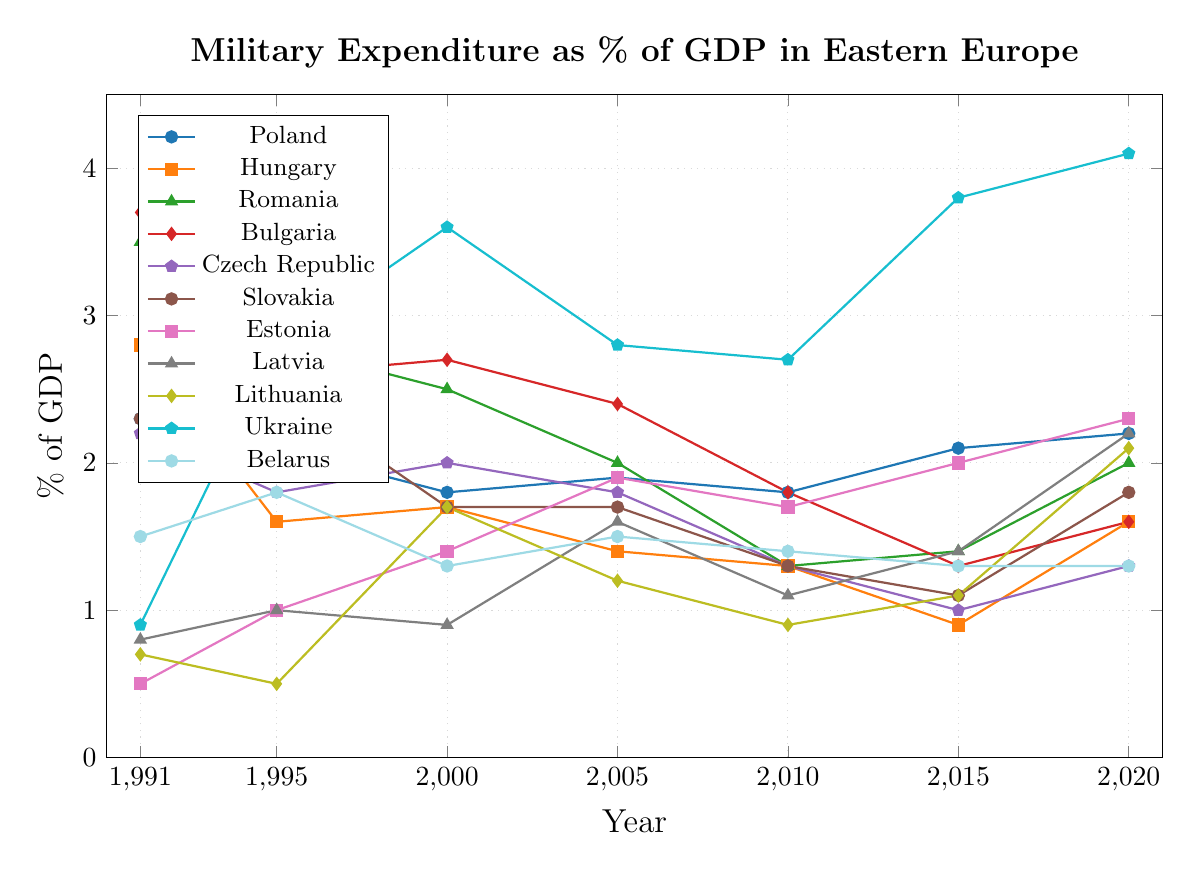What is the trend of military expenditure as a percentage of GDP for Estonia from 1991 to 2020? The figure shows a steady increase in military expenditure for Estonia, starting at 0.5% in 1991 and rising to 2.3% by 2020. The values are 0.5% (1991), 1.0% (1995), 1.4% (2000), 1.9% (2005), 1.7% (2010), 2.0% (2015), and 2.3% (2020).
Answer: Increasing Which country had the highest military expenditure as a percentage of GDP in 1991 and what was it? In 1991, Bulgaria had the highest military expenditure as a percentage of GDP at 3.7%. This can be determined by comparing the 1991 values for all countries.
Answer: Bulgaria, 3.7% Which country had the most significant decline in military expenditure as a percentage of GDP between 1991 and 2015? To determine this, calculate the difference between 1991 and 2015 for each country and identify the largest decline. Hungary's expenditure dropped from 2.8% in 1991 to 0.9% in 2015, a decrease of 1.9 percentage points.
Answer: Hungary Compare the military expenditures as a percentage of GDP in 2010 and 2020 for Ukraine and determine the difference. For Ukraine, the expenditure was 2.7% in 2010 and 4.1% in 2020. The difference is 4.1% - 2.7% = 1.4%.
Answer: 1.4% What is the average military expenditure as a percentage of GDP for Poland across all given years? Add the values for Poland (2.3 + 2.1 + 1.8 + 1.9 + 1.8 + 2.1 + 2.2) and divide by the number of years: (2.3 + 2.1 + 1.8 + 1.9 + 1.8 + 2.1 + 2.2) / 7 = 2.03.
Answer: 2.03% Which country had the highest military expenditure as a percentage of GDP in 2020, and what was the value? In 2020, Ukraine had the highest expenditure at 4.1%. By examining each country's value for 2020, Ukraine's 4.1% is the highest.
Answer: Ukraine, 4.1% By how much did Latvia's military expenditure as a percentage of GDP change from 2015 to 2020? In 2015, Latvia's expenditure was 1.4%, and in 2020 it was 2.2%. The change is 2.2% - 1.4% = 0.8%.
Answer: 0.8% What is the overall trend of military expenditure in Belarus from 1991 to 2020? The trend for Belarus shows relatively stable military expenditure. In 1991, it was 1.5%, in 1995 it rose to 1.8%, then fluctuated slightly, staying between 1.3% and 1.5% in later years.
Answer: Stable Which three countries showed an increase in military expenditure as a percentage of GDP from 2015 to 2020? Comparing the values from 2015 to 2020, the countries that showed an increase are Hungary (0.9% to 1.6%), Estonia (2.0% to 2.3%), and Lithuania (1.1% to 2.1%).
Answer: Hungary, Estonia, Lithuania What was the military expenditure as a percentage of GDP for Romania in 2000, and how did it compare to Bulgaria in the same year? Romania's expenditure in 2000 was 2.5%, whereas Bulgaria's was 2.7%. Romania's expenditure was 0.2 percentage points lower than Bulgaria's.
Answer: Romania: 2.5%, Bulgaria: 2.7%, 0.2 percentage points lower 